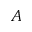Convert formula to latex. <formula><loc_0><loc_0><loc_500><loc_500>A</formula> 